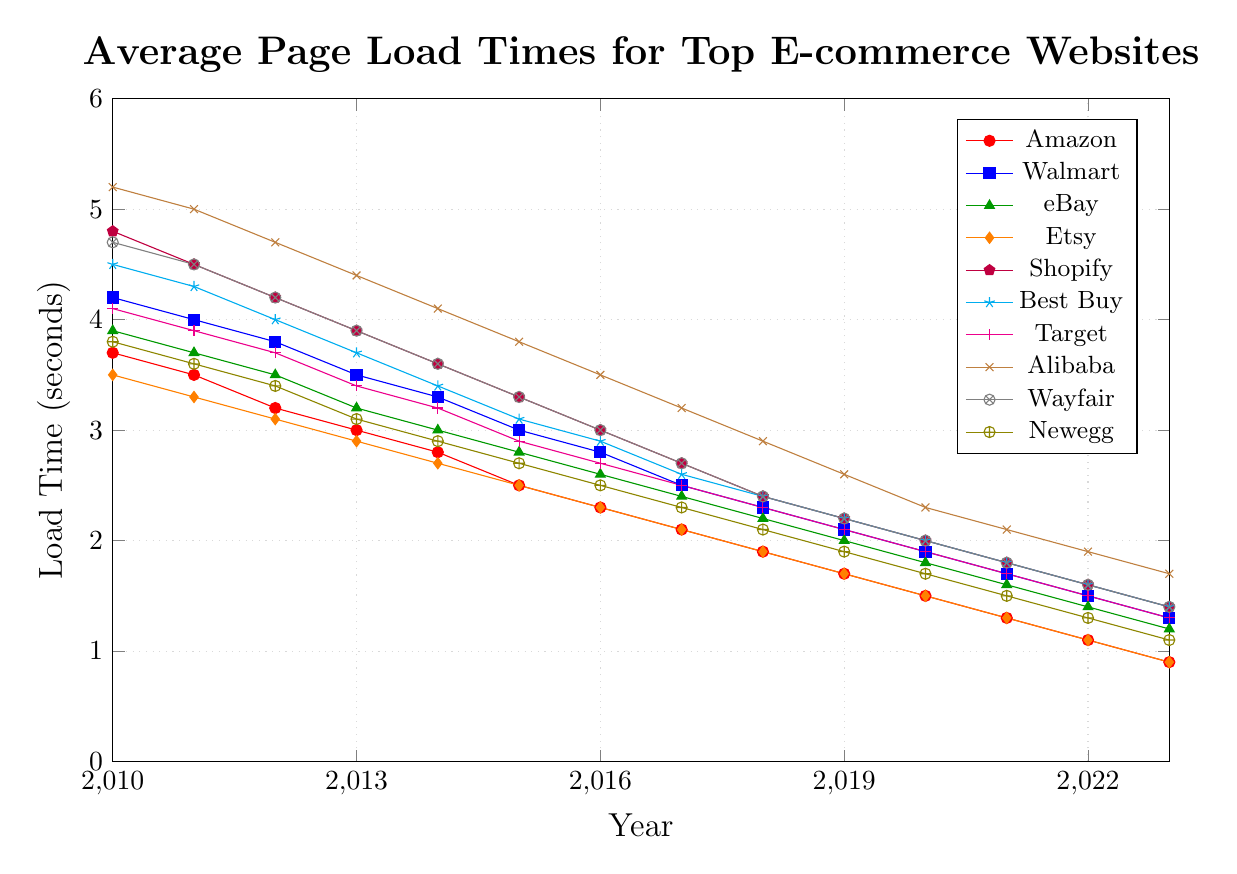What's the trend in Amazon's page load times from 2010 to 2023? From the figure, observe the line representing Amazon's page load times. The trend shows a consistent decrease from 3.7 seconds in 2010 to 0.9 seconds in 2023.
Answer: Decreasing Which website had the highest average page load time in 2010? Refer to the data points for each line at the 2010 mark. Alibaba had the highest value, which is 5.2 seconds.
Answer: Alibaba Between 2010 and 2015, which website showed the greatest decrease in page load time, and what was the difference? Calculate the difference for each website from 2010 to 2015:
- Amazon: 3.7 - 2.5 = 1.2
- Walmart: 4.2 - 3.0 = 1.2
- eBay: 3.9 - 2.8 = 1.1
- Etsy: 3.5 - 2.5 = 1.0
- Shopify: 4.8 - 3.3 = 1.5
- Best Buy: 4.5 - 3.1 = 1.4
- Target: 4.1 - 2.9 = 1.2
- Alibaba: 5.2 - 3.8 = 1.4
- Wayfair: 4.7 - 3.3 = 1.4
- Newegg: 3.8 - 2.7 = 1.1
Shopify showed the greatest decrease of 1.5 seconds.
Answer: Shopify, 1.5 seconds How did Etsy's page load time in 2023 compare to its page load time in 2010? Compare the values for Etsy in 2010 and 2023. In 2010, it was 3.5 seconds; in 2023, it is 0.9 seconds. There was a significant decrease.
Answer: Decreased significantly Which websites had page load times below 2 seconds in 2020? Check the data points for the year 2020 for each website:
- Amazon: 1.5
- Walmart: 1.9
- eBay: 1.8
- Etsy: 1.5
- Shopify: 2.0
- Best Buy: 2.0
- Target: 1.9
- Alibaba: 2.3
- Wayfair: 2.0
- Newegg: 1.7
Websites with load times below 2 seconds: Amazon, Walmart, eBay, Etsy, Target, Newegg.
Answer: Amazon, Walmart, eBay, Etsy, Target, Newegg On average, how much did the page load times for Newegg improve per year from 2010 to 2023? Calculate the overall difference and then the average yearly improvement:
Total improvement = 3.8 - 1.1 = 2.7 seconds
Number of years = 2023 - 2010 = 13 years
Average improvement per year = 2.7 / 13 ≈ 0.21 seconds
Answer: 0.21 seconds per year Which two websites had the closest page load times in 2016, and what were their values? Compare the data points for all websites in 2016.
- Amazon: 2.3
- Walmart: 2.8
- eBay: 2.6
- Etsy: 2.3
- Shopify: 3.0
- Best Buy: 2.9
- Target: 2.7
- Alibaba: 3.5
- Wayfair: 3.0
- Newegg: 2.5
The closest values are Amazon (2.3) and Etsy (2.3).
Answer: Amazon and Etsy, 2.3 seconds 